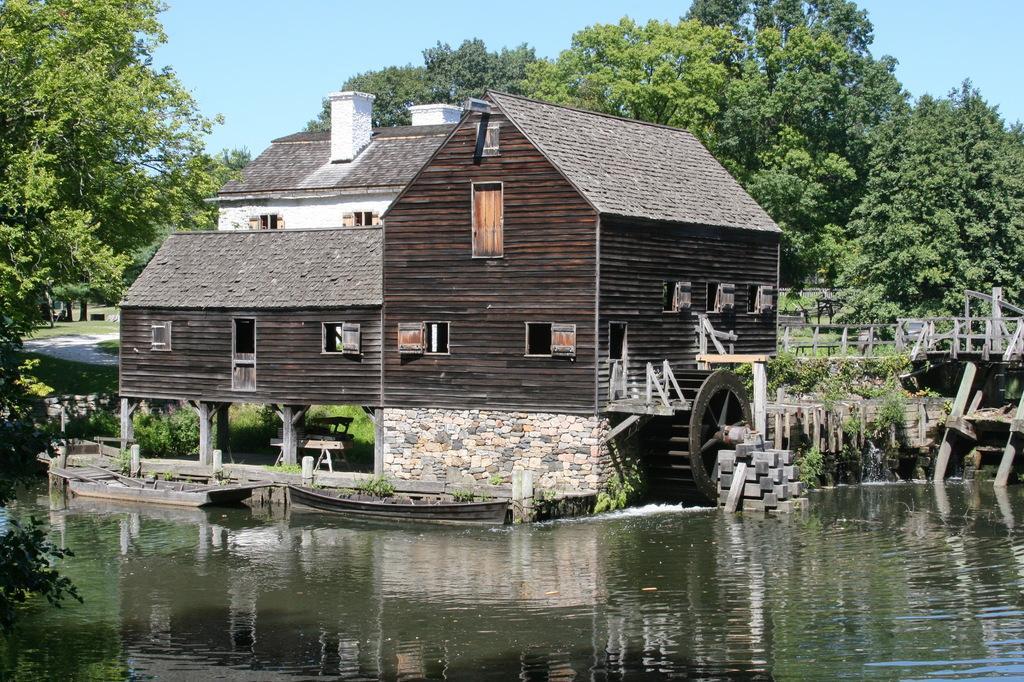Please provide a concise description of this image. There is a surface of water at the bottom of this image and there is a building in the middle of this image. We can see some trees in the background and there is a sky at the top of this image. 